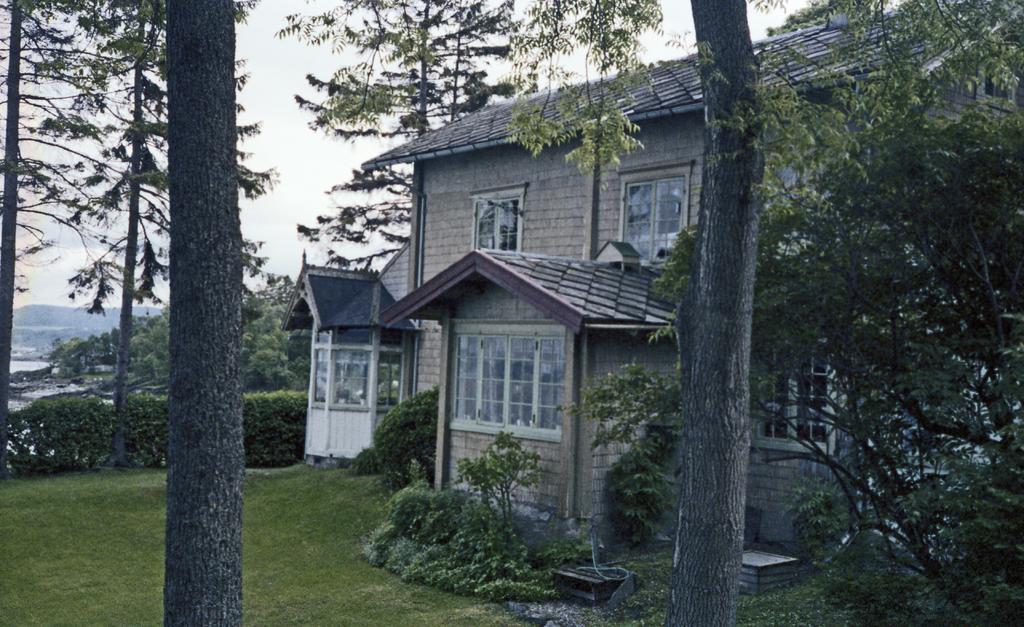Describe this image in one or two sentences. In this image in the front there are trees. In the center there are plants, there's grass on the ground, there is a house and there are trees, the sky is cloudy and there is water. 